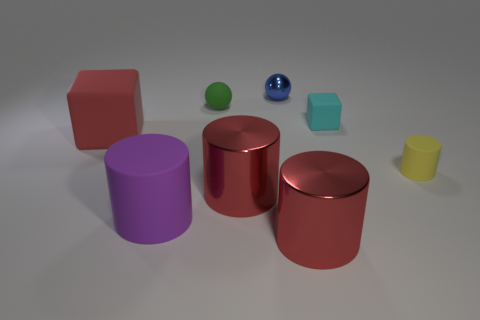Subtract 1 cylinders. How many cylinders are left? 3 Add 1 red rubber cubes. How many objects exist? 9 Subtract all balls. How many objects are left? 6 Add 8 red metal things. How many red metal things exist? 10 Subtract 1 yellow cylinders. How many objects are left? 7 Subtract all small blue metal objects. Subtract all tiny purple rubber spheres. How many objects are left? 7 Add 5 small blocks. How many small blocks are left? 6 